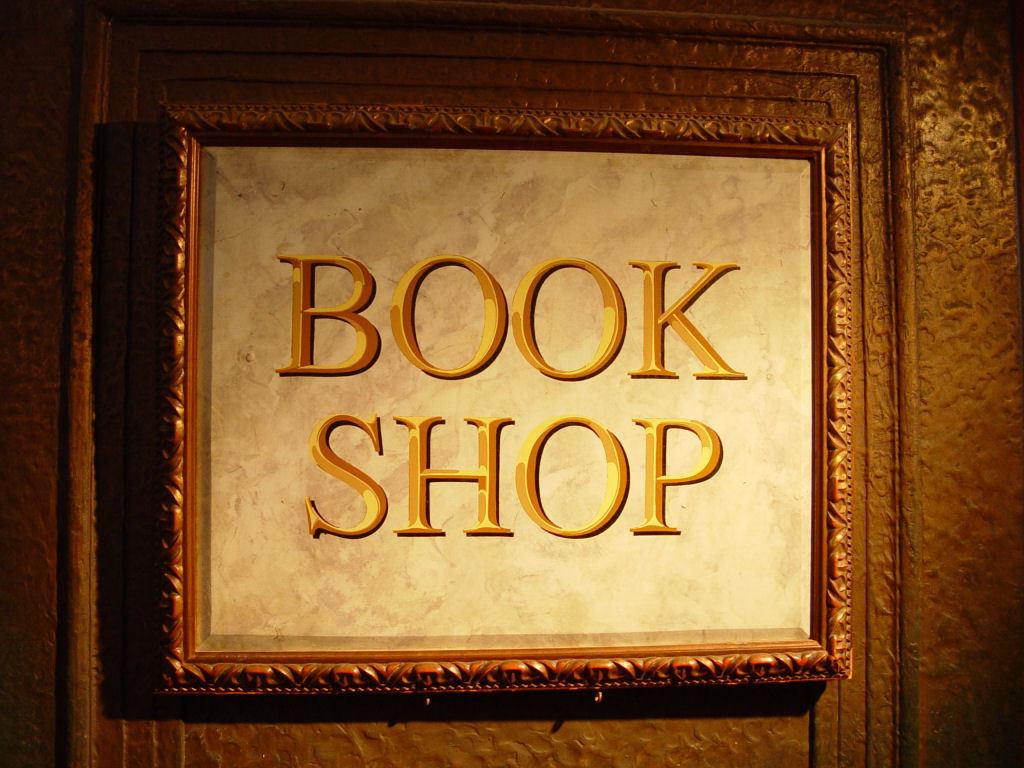What kind of shop?
Give a very brief answer. Book. 